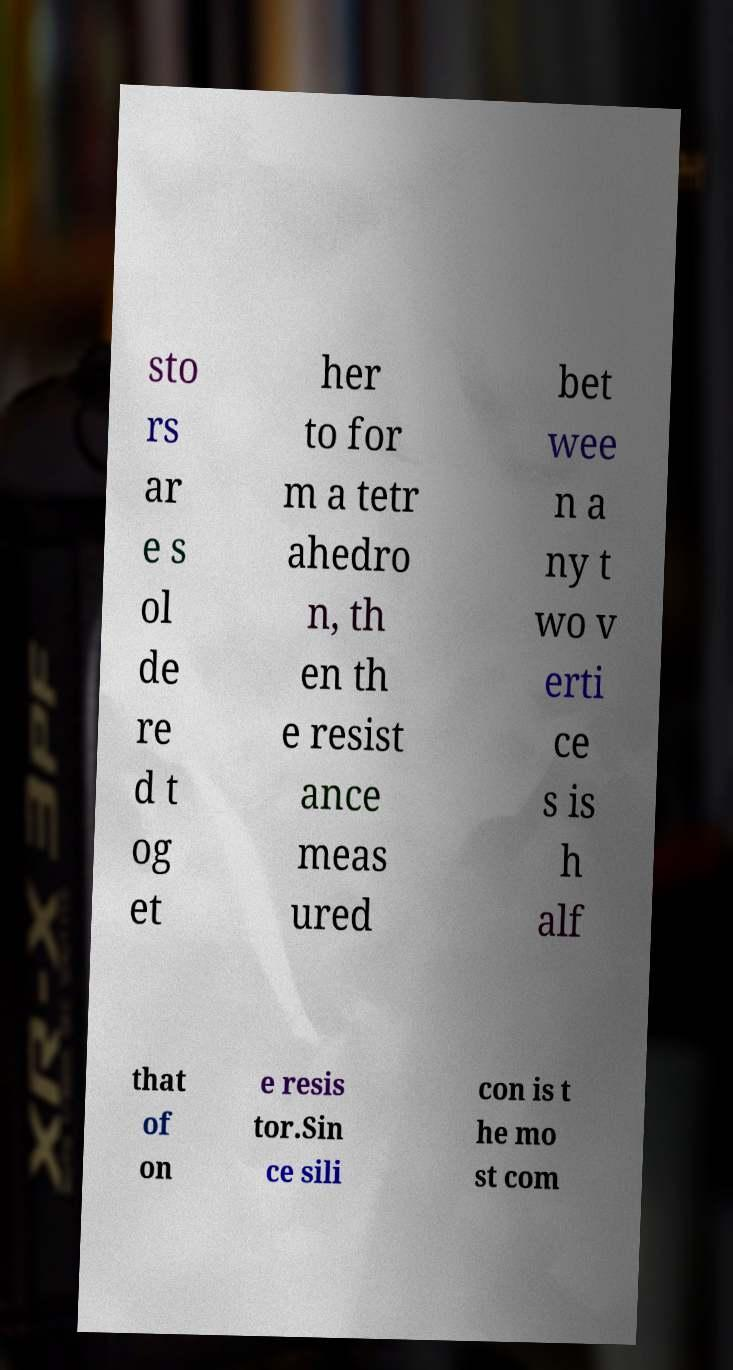I need the written content from this picture converted into text. Can you do that? sto rs ar e s ol de re d t og et her to for m a tetr ahedro n, th en th e resist ance meas ured bet wee n a ny t wo v erti ce s is h alf that of on e resis tor.Sin ce sili con is t he mo st com 